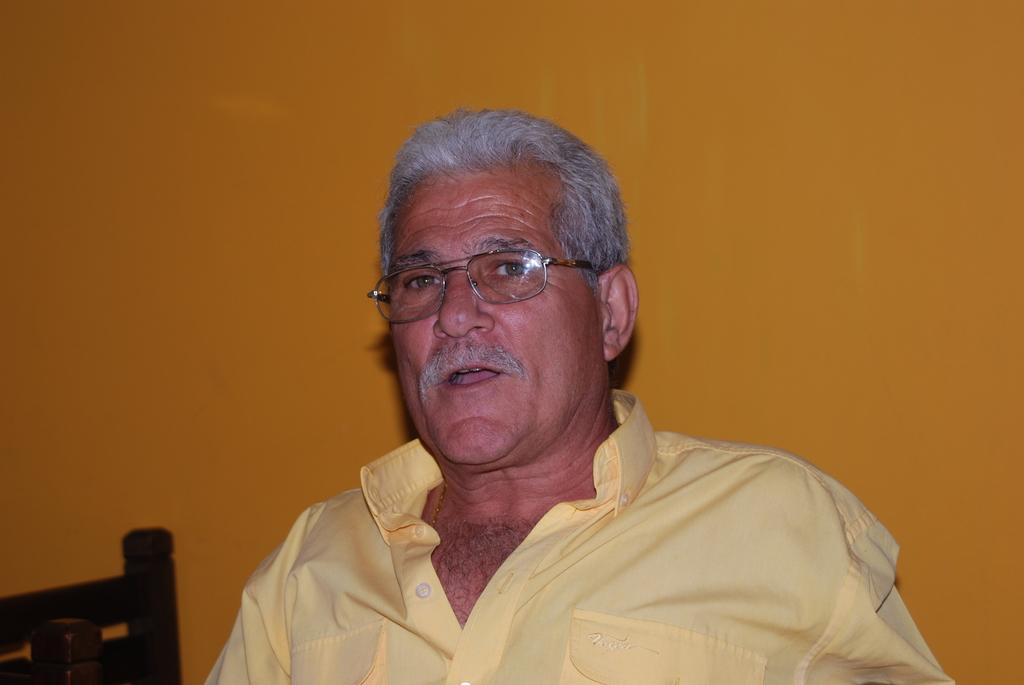What is the main subject of the image? There is a person in the image. What is the person wearing? The person is wearing a yellow dress and specs. What color is the background of the image? The background of the image is yellow. Can you see any ants crawling on the person's dress in the image? There are no ants visible in the image. What type of wine is being served in the image? There is no wine present in the image. 